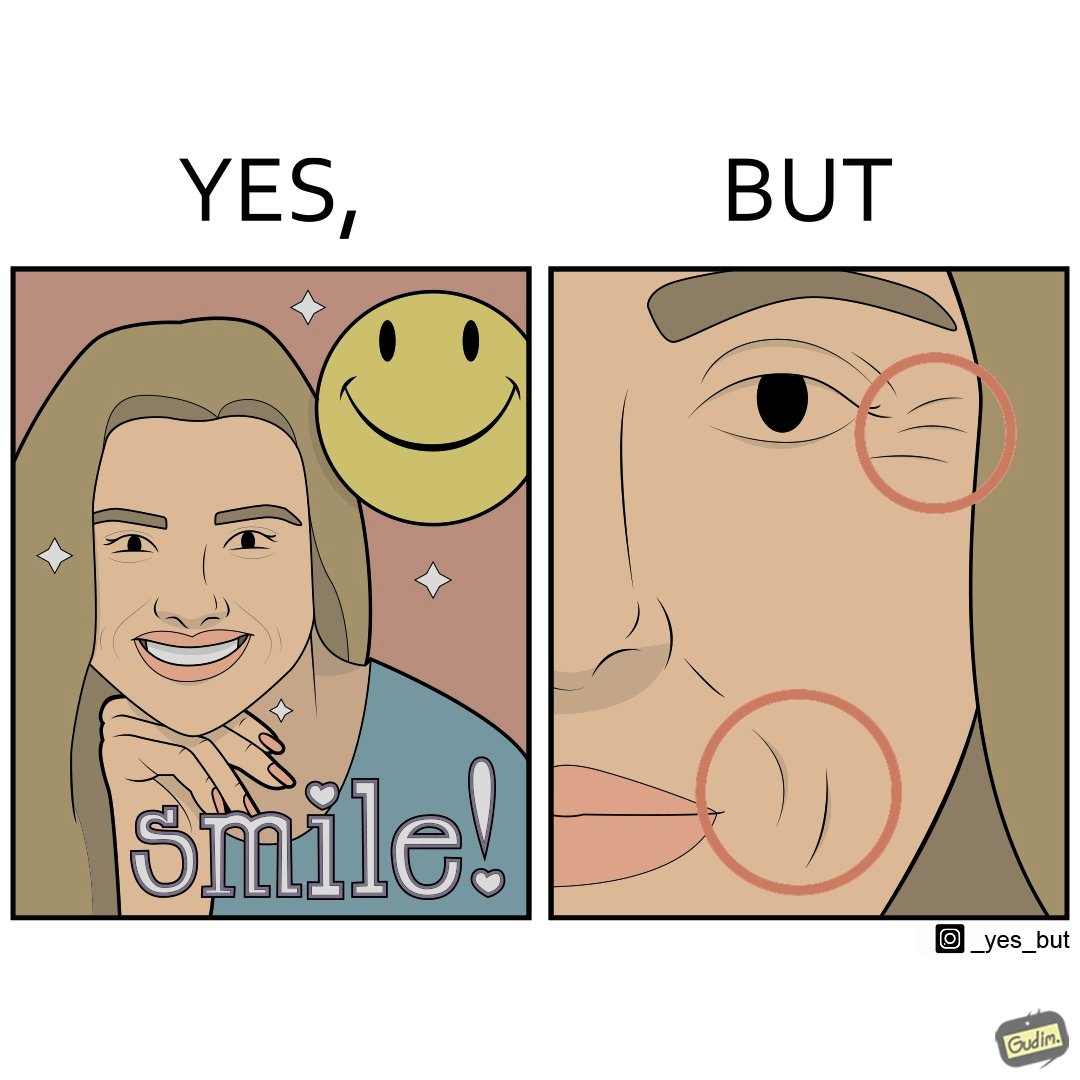Provide a description of this image. The image is ironical because while it suggests people to smile it also shows the wrinkles that can be caused around lips and eyes because of smiling 